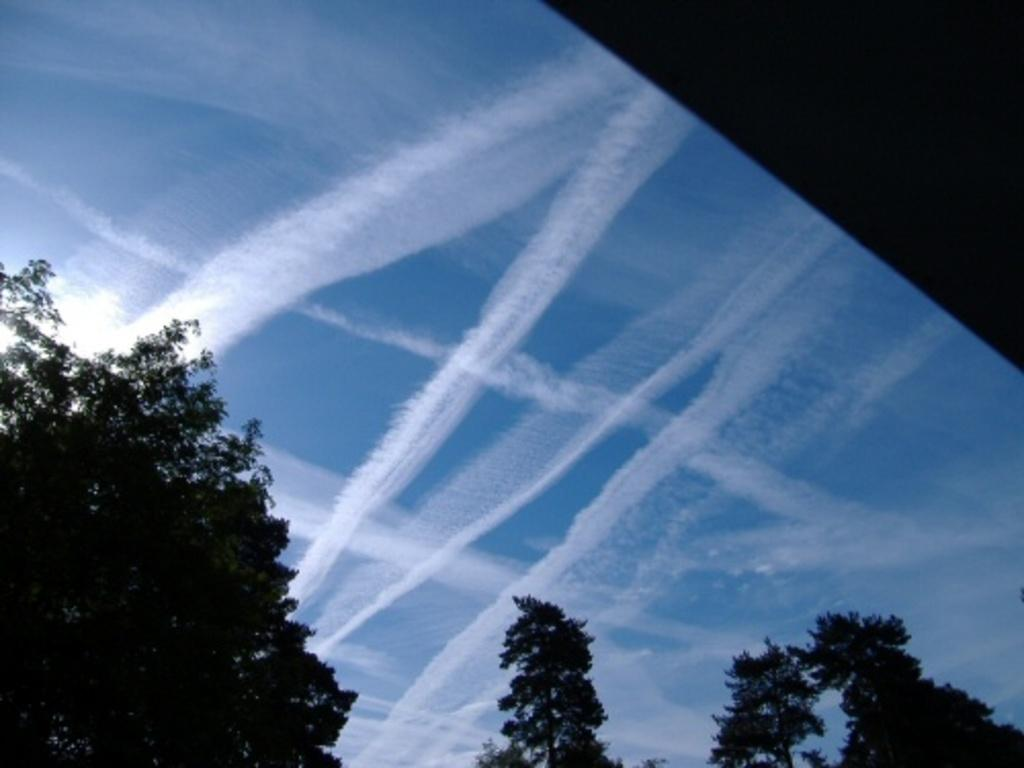What can be seen in the sky in the image? There are clouds visible in the sky. What type of vegetation is present in the image? There are trees in the image. What type of horn can be seen in the image? There is no horn present in the image. What yard-related activity is taking place in the image? There is no yard or yard-related activity present in the image. 